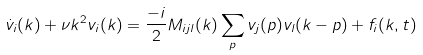Convert formula to latex. <formula><loc_0><loc_0><loc_500><loc_500>\dot { v } _ { i } ( { k } ) + \nu k ^ { 2 } v _ { i } ( { k } ) = \frac { - i } { 2 } M _ { i j l } ( { k } ) \sum _ { p } v _ { j } ( { p } ) v _ { l } ( { k - p } ) + f _ { i } ( { k } , t )</formula> 